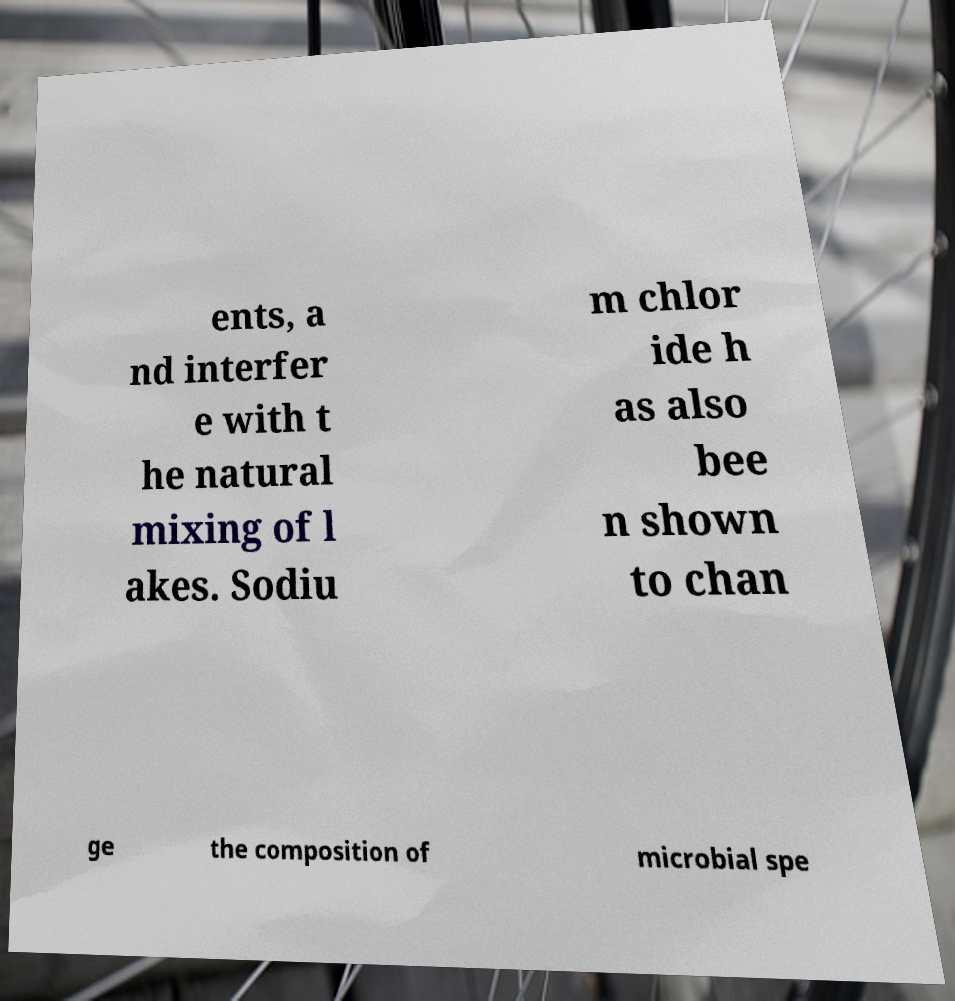Could you extract and type out the text from this image? ents, a nd interfer e with t he natural mixing of l akes. Sodiu m chlor ide h as also bee n shown to chan ge the composition of microbial spe 